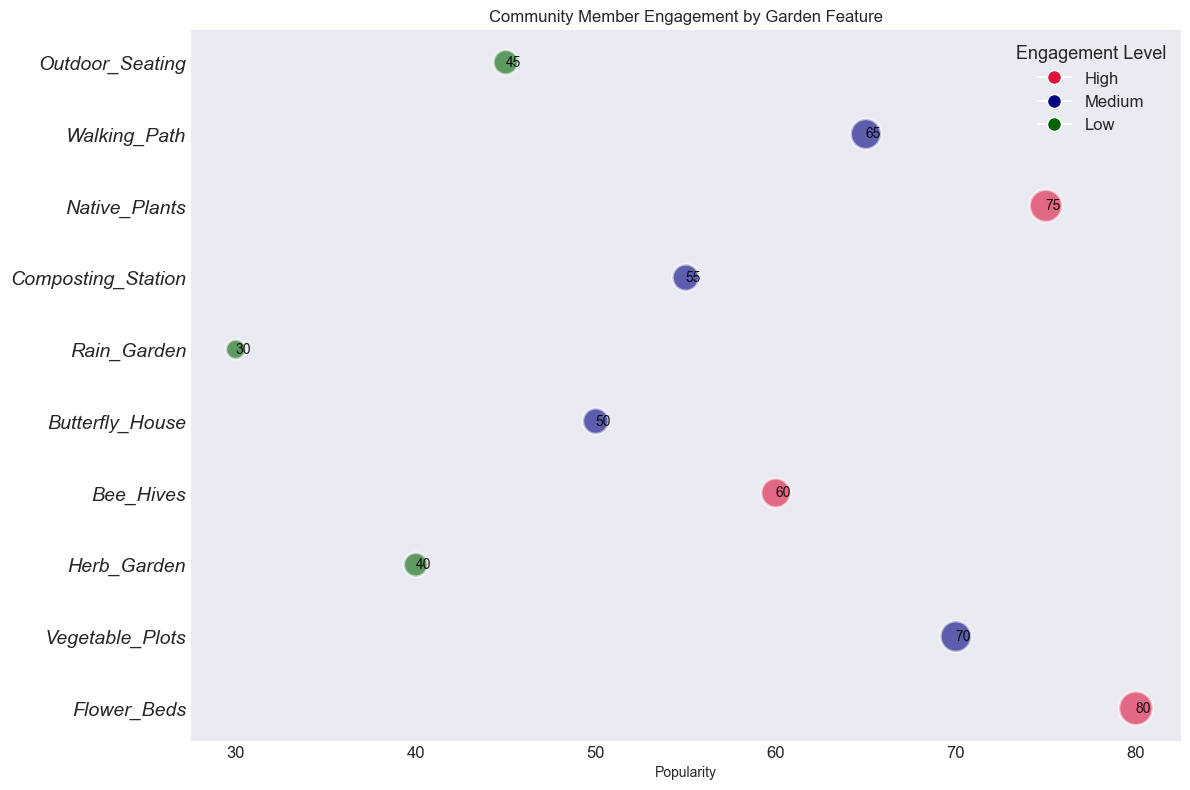Which garden feature has the highest popularity? To find this, look for the highest value on the x-axis (Popularity). The feature at this value is "Flower_Beds" with a popularity of 80.
Answer: Flower_Beds Which two features have the same engagement level and compare their popularity? Both "Walking_Path" and "Butterfly_House" have a Medium engagement level. Comparing their popularity values, we see "Walking_Path" has 65 and "Butterfly_House" has 50.
Answer: Walking_Path has higher popularity than Butterfly_House What is the total bubble size for features with High engagement levels? First, identify features with High engagement levels: Flower_Beds (60), Bee_Hives (45), and Native_Plants (55). Sum their bubble sizes: 60 + 45 + 55 = 160
Answer: 160 Which feature has the lowest popularity, and what is its engagement level? Identify the lowest value on the x-axis (Popularity). "Rain_Garden" has the lowest popularity at 30. Its engagement level is Low.
Answer: Rain_Garden, Low Which feature with a Low engagement level has the largest bubble size? Identify features with Low engagement levels: Herb_Garden (30), Rain_Garden (20), Outdoor_Seating (32). Outdoor_Seating has the largest bubble size at 32.
Answer: Outdoor_Seating How many features have a popularity greater than 50? Count the features with a popularity value above 50. They are: Flower_Beds (80), Vegetable_Plots (70), Bee_Hives (60), Butterfly_House (50), Native_Plants (75), and Walking_Path (65). Thus, there are 6 features.
Answer: 6 Consider features with Medium engagement levels, what is the average popularity? Identify features with Medium engagement levels: Vegetable_Plots (70), Butterfly_House (50), Composting_Station (55), Walking_Path (65). Sum their popularity values: 70 + 50 + 55 + 65 = 240. Average is 240/4 = 60.
Answer: 60 What is the gap in Popularity between the most and least popular features? Find the most popular feature, which is Flower_Beds at 80, and the least popular feature, which is Rain_Garden at 30. The gap is 80 - 30 = 50.
Answer: 50 Which garden feature has the highest bubble size, and what is its engagement level and popularity? The highest bubble size is 60, which corresponds to Flower_Beds. Its engagement level is High, and popularity is 80.
Answer: Flower_Beds, High, 80 